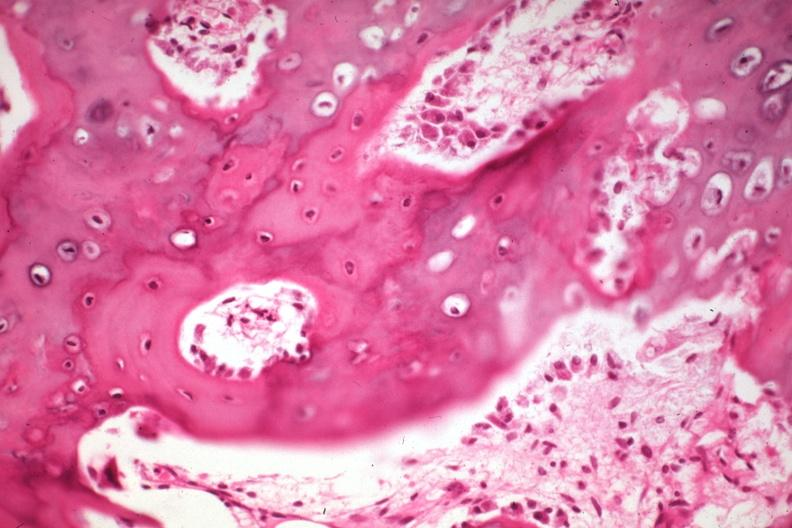what does this image show?
Answer the question using a single word or phrase. High excellent new bone formation with osteoblasts 